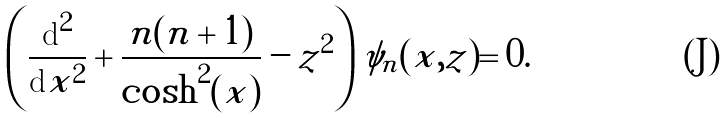Convert formula to latex. <formula><loc_0><loc_0><loc_500><loc_500>\left ( \frac { \text {d} ^ { 2 } } { \text {d} x ^ { 2 } } + \frac { n ( n + 1 ) } { \cosh ^ { 2 } ( x ) } - z ^ { 2 } \right ) \psi _ { n } ( x , z ) = 0 .</formula> 